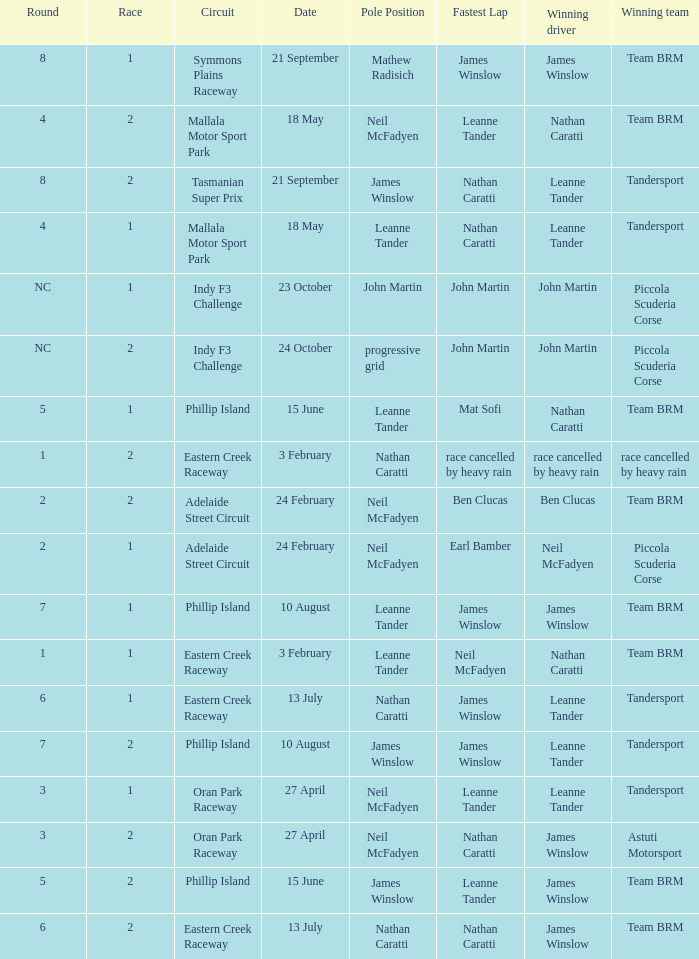Which race number in the Indy F3 Challenge circuit had John Martin in pole position? 1.0. 